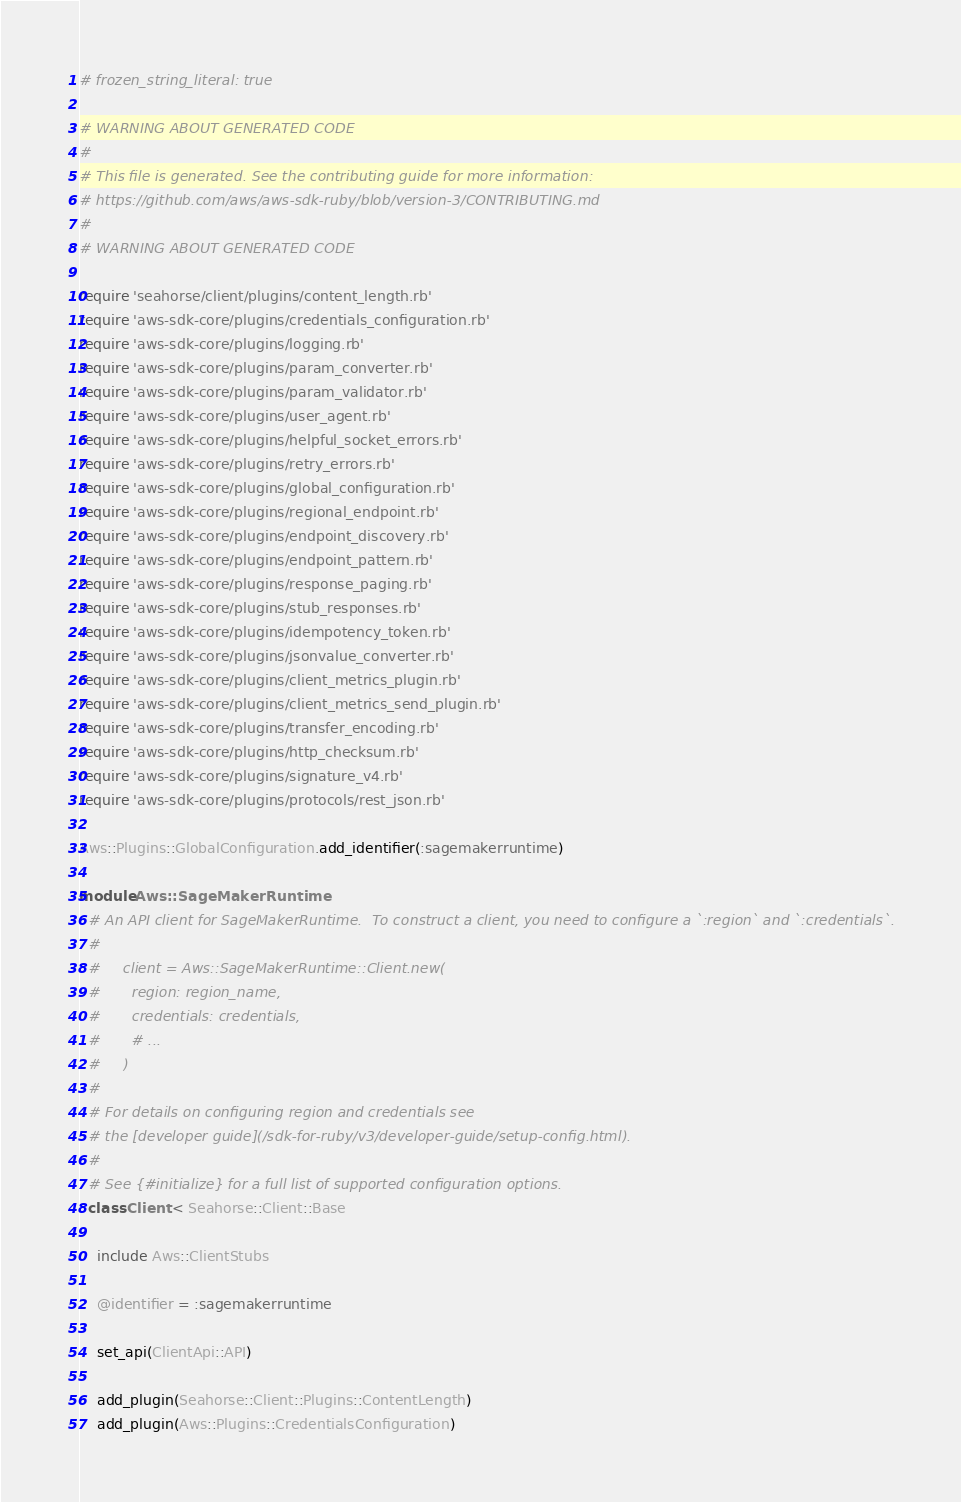Convert code to text. <code><loc_0><loc_0><loc_500><loc_500><_Ruby_># frozen_string_literal: true

# WARNING ABOUT GENERATED CODE
#
# This file is generated. See the contributing guide for more information:
# https://github.com/aws/aws-sdk-ruby/blob/version-3/CONTRIBUTING.md
#
# WARNING ABOUT GENERATED CODE

require 'seahorse/client/plugins/content_length.rb'
require 'aws-sdk-core/plugins/credentials_configuration.rb'
require 'aws-sdk-core/plugins/logging.rb'
require 'aws-sdk-core/plugins/param_converter.rb'
require 'aws-sdk-core/plugins/param_validator.rb'
require 'aws-sdk-core/plugins/user_agent.rb'
require 'aws-sdk-core/plugins/helpful_socket_errors.rb'
require 'aws-sdk-core/plugins/retry_errors.rb'
require 'aws-sdk-core/plugins/global_configuration.rb'
require 'aws-sdk-core/plugins/regional_endpoint.rb'
require 'aws-sdk-core/plugins/endpoint_discovery.rb'
require 'aws-sdk-core/plugins/endpoint_pattern.rb'
require 'aws-sdk-core/plugins/response_paging.rb'
require 'aws-sdk-core/plugins/stub_responses.rb'
require 'aws-sdk-core/plugins/idempotency_token.rb'
require 'aws-sdk-core/plugins/jsonvalue_converter.rb'
require 'aws-sdk-core/plugins/client_metrics_plugin.rb'
require 'aws-sdk-core/plugins/client_metrics_send_plugin.rb'
require 'aws-sdk-core/plugins/transfer_encoding.rb'
require 'aws-sdk-core/plugins/http_checksum.rb'
require 'aws-sdk-core/plugins/signature_v4.rb'
require 'aws-sdk-core/plugins/protocols/rest_json.rb'

Aws::Plugins::GlobalConfiguration.add_identifier(:sagemakerruntime)

module Aws::SageMakerRuntime
  # An API client for SageMakerRuntime.  To construct a client, you need to configure a `:region` and `:credentials`.
  #
  #     client = Aws::SageMakerRuntime::Client.new(
  #       region: region_name,
  #       credentials: credentials,
  #       # ...
  #     )
  #
  # For details on configuring region and credentials see
  # the [developer guide](/sdk-for-ruby/v3/developer-guide/setup-config.html).
  #
  # See {#initialize} for a full list of supported configuration options.
  class Client < Seahorse::Client::Base

    include Aws::ClientStubs

    @identifier = :sagemakerruntime

    set_api(ClientApi::API)

    add_plugin(Seahorse::Client::Plugins::ContentLength)
    add_plugin(Aws::Plugins::CredentialsConfiguration)</code> 